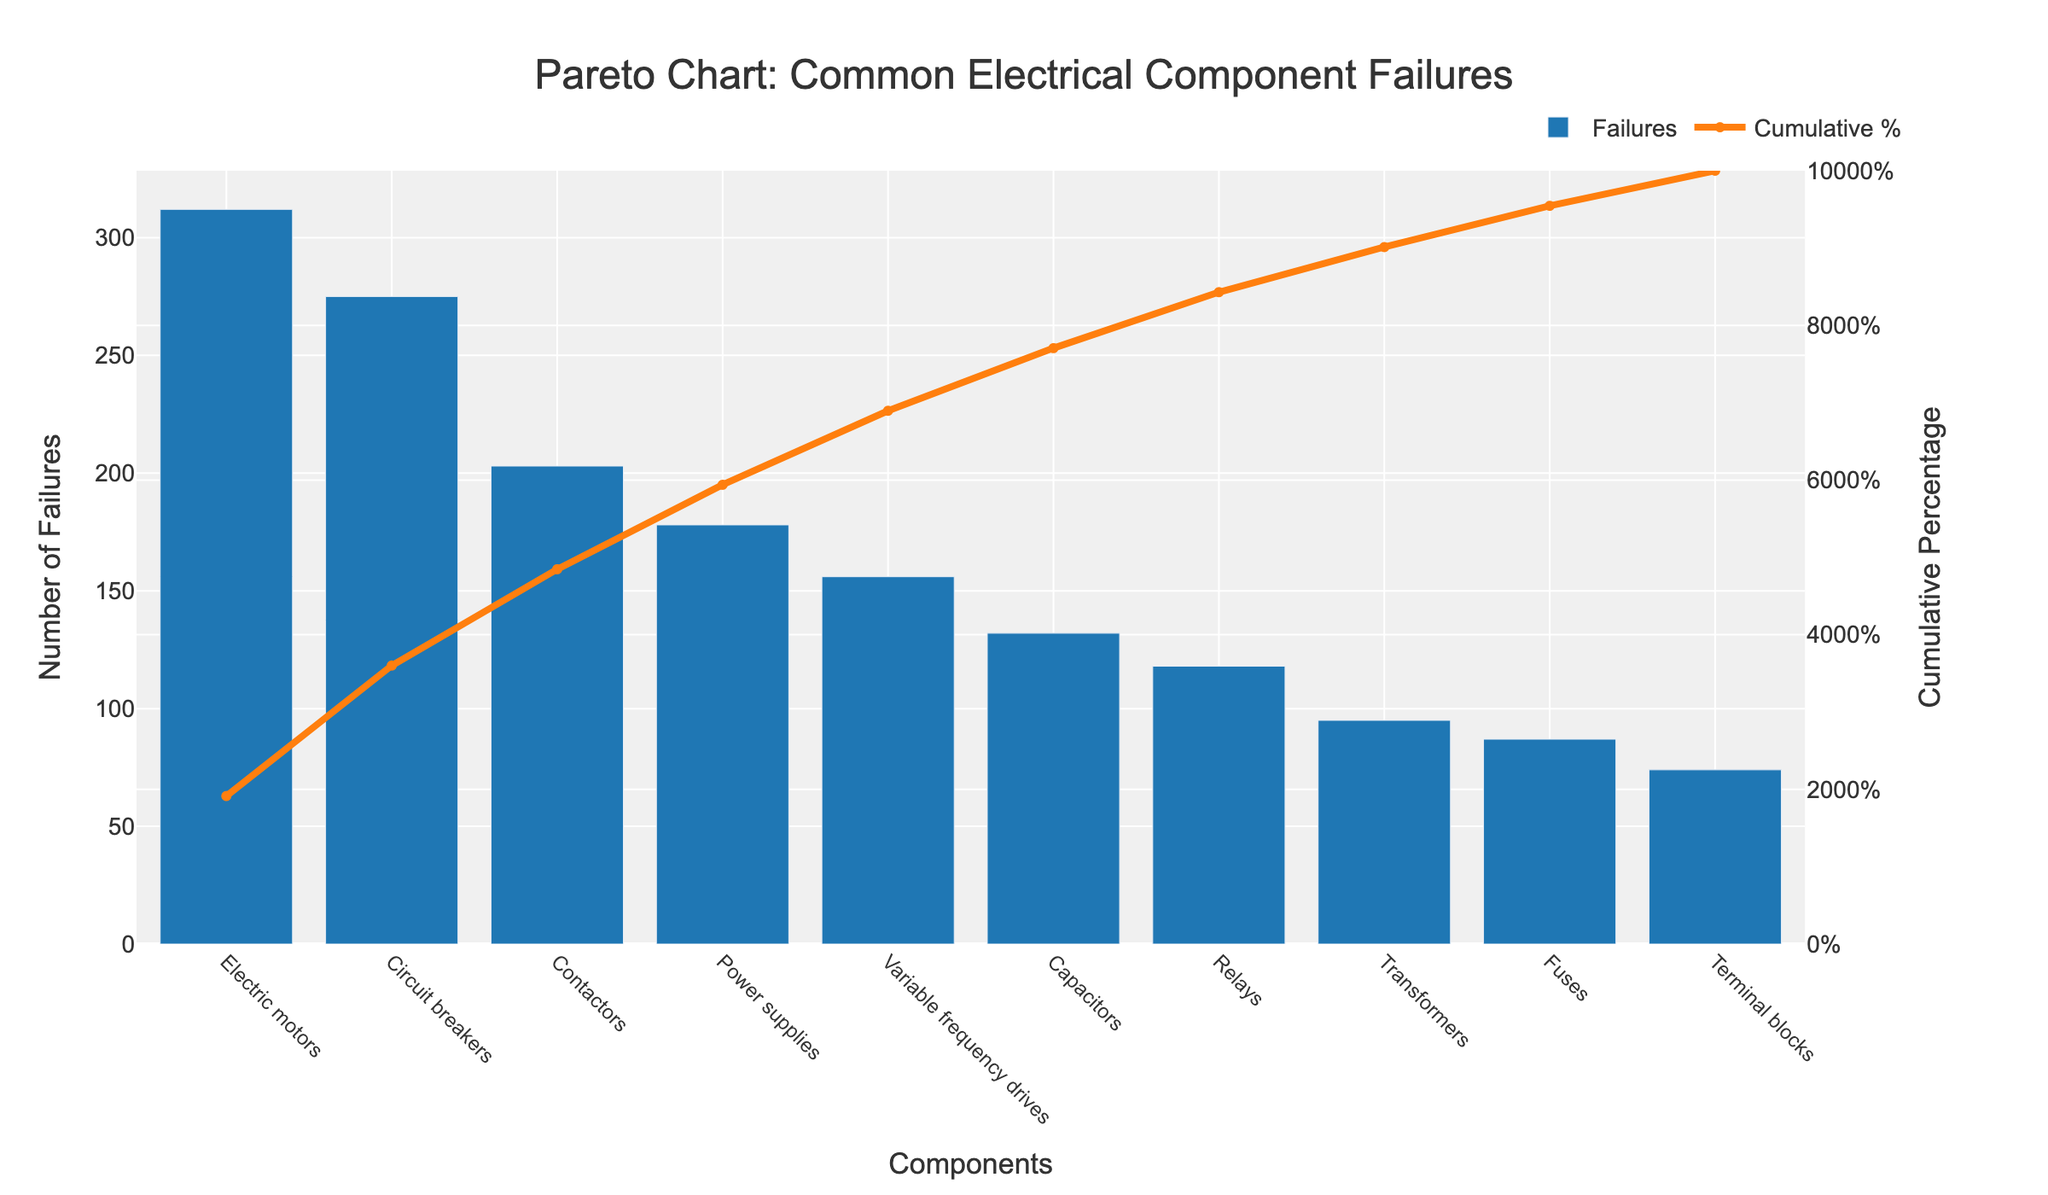What is the title of the chart? The title of the chart is usually located at the top and describes what the chart represents. In this case, it states that the chart is about common electrical component failures.
Answer: Pareto Chart: Common Electrical Component Failures What is the color of the bar representing the number of failures? The color used for the bars can provide visual differentiation from other elements, such as the line for cumulative percentage. The bar color is mentioned in the code as a specific blue.
Answer: Blue Which component has the highest number of failures? The bar chart part of the Pareto chart clearly shows the number of failures for each component. The component with the tallest bar is the one with the highest number of failures.
Answer: Electric motors What's the cumulative percentage for the first three components? To find the answer, add the cumulative percentages of the first three components from left to right. The cumulative percentages for Electric motors, Circuit breakers, and Contactors are provided along the line graph.
Answer: 47.2% (Electric motors) + 89.6% (Circuit breakers) + 136.6% (Contactors) = 136.6% What is the approximate cumulative percentage after the variable frequency drives (the fifth component from the left)? Look at the cumulative percentage line plot and find the percentage corresponding to the fifth component's position on the x-axis.
Answer: Around 86.2% Which component has fewer failures: relays or capacitors? Compare the heights of the bars for relays and capacitors. The taller bar indicates more failures.
Answer: Relays Does the Pareto principle (80/20 rule) apply to this chart? If yes, up to which component? The Pareto principle suggests that 80% of the problems come from 20% of the causes. Check if a small percentage of components (20%) account for a large percentage of failures (80%).
Answer: Yes, up to Power supplies How many components in total are depicted on the x-axis? Count the number of distinct bars along the x-axis, each representing a different component.
Answer: 10 What is the trend in the cumulative percentage as you move from left to right on the x-axis? Observe the line representing the cumulative percentage; a gradual increase indicates an accumulation of the percentage as each component is added.
Answer: Increasing 